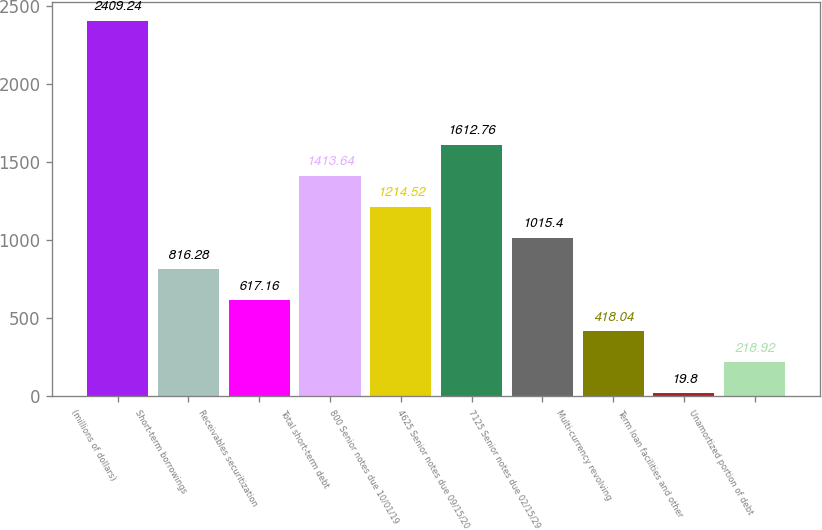Convert chart to OTSL. <chart><loc_0><loc_0><loc_500><loc_500><bar_chart><fcel>(millions of dollars)<fcel>Short-term borrowings<fcel>Receivables securitization<fcel>Total short-term debt<fcel>800 Senior notes due 10/01/19<fcel>4625 Senior notes due 09/15/20<fcel>7125 Senior notes due 02/15/29<fcel>Multi-currency revolving<fcel>Term loan facilities and other<fcel>Unamortized portion of debt<nl><fcel>2409.24<fcel>816.28<fcel>617.16<fcel>1413.64<fcel>1214.52<fcel>1612.76<fcel>1015.4<fcel>418.04<fcel>19.8<fcel>218.92<nl></chart> 